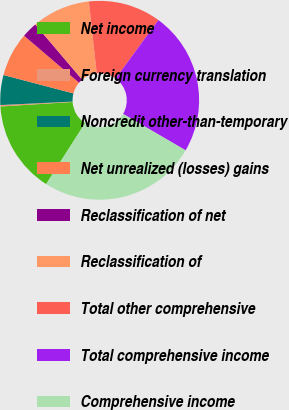<chart> <loc_0><loc_0><loc_500><loc_500><pie_chart><fcel>Net income<fcel>Foreign currency translation<fcel>Noncredit other-than-temporary<fcel>Net unrealized (losses) gains<fcel>Reclassification of net<fcel>Reclassification of<fcel>Total other comprehensive<fcel>Total comprehensive income<fcel>Comprehensive income<nl><fcel>14.96%<fcel>0.23%<fcel>4.85%<fcel>7.16%<fcel>2.54%<fcel>9.47%<fcel>11.78%<fcel>23.33%<fcel>25.64%<nl></chart> 